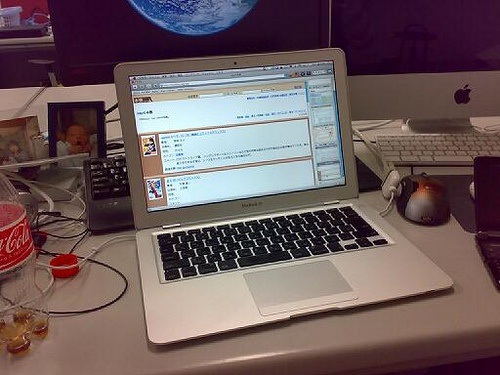Describe the objects in this image and their specific colors. I can see laptop in purple, darkgray, gray, lightblue, and black tones, tv in purple, black, gray, navy, and blue tones, keyboard in purple, black, darkgray, gray, and lightgray tones, keyboard in purple, black, and gray tones, and keyboard in purple, gray, and maroon tones in this image. 